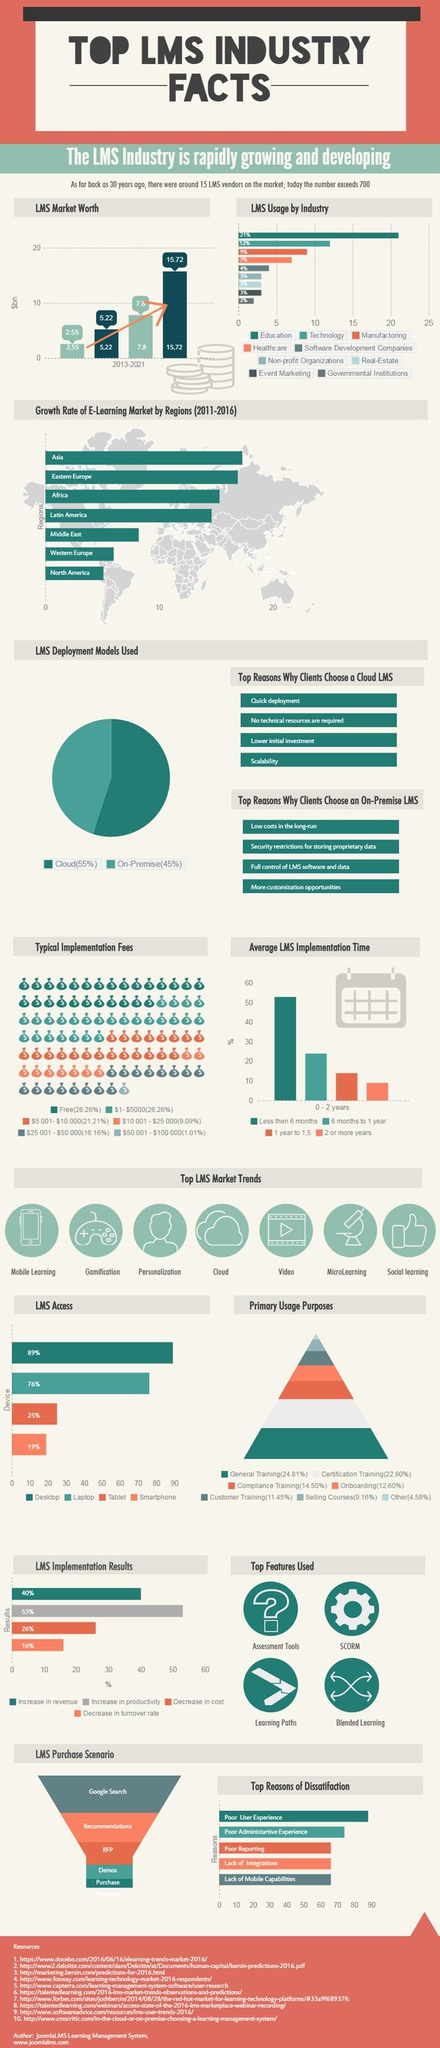Identify some key points in this picture. Nine industries use LMS. The Middle East, Western Europe, and North America have growth rates in the e-Learning market that are less than 10%. According to a recent survey, LMS usage in the manufacturing industry is estimated to be approximately 9%. The e-learning market in Europe is experiencing high growth rates, with the East region showing the highest growth. Specifically, the East region is seeing a significant increase in the adoption of e-learning, indicating that it is a promising area for further investment and development. The cloud-based LMS deployment model is more costly in the long run compared to the self-hosted LMS deployment model. 